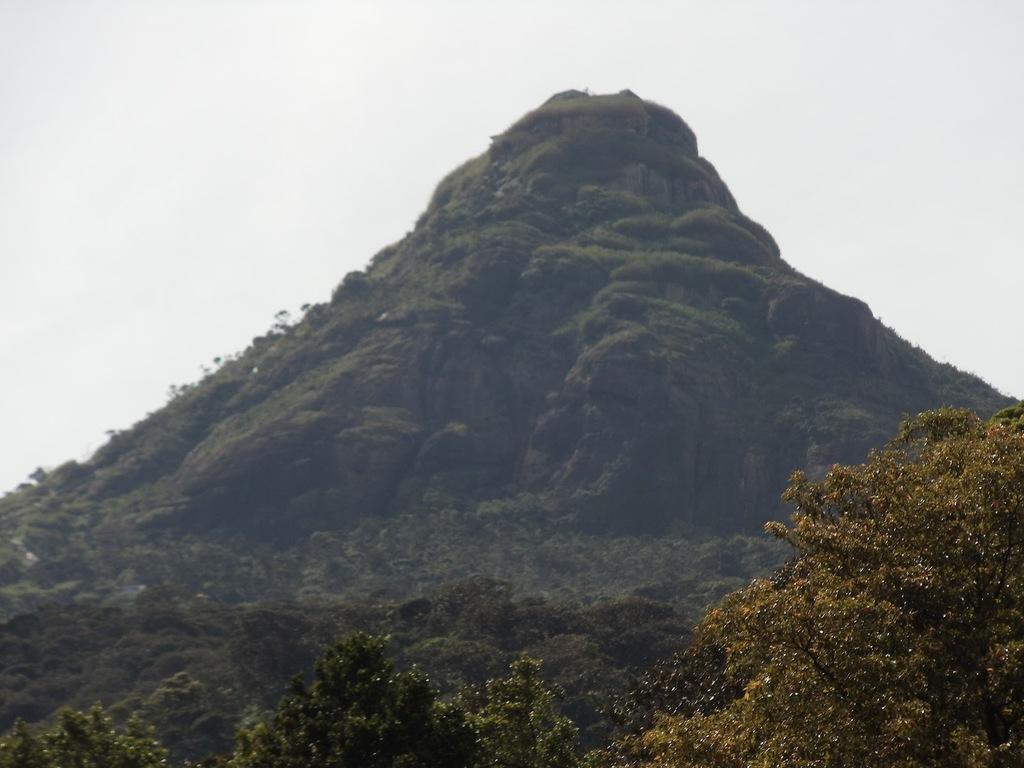Describe this image in one or two sentences. In the center of the image there is a mountain. There are trees. 